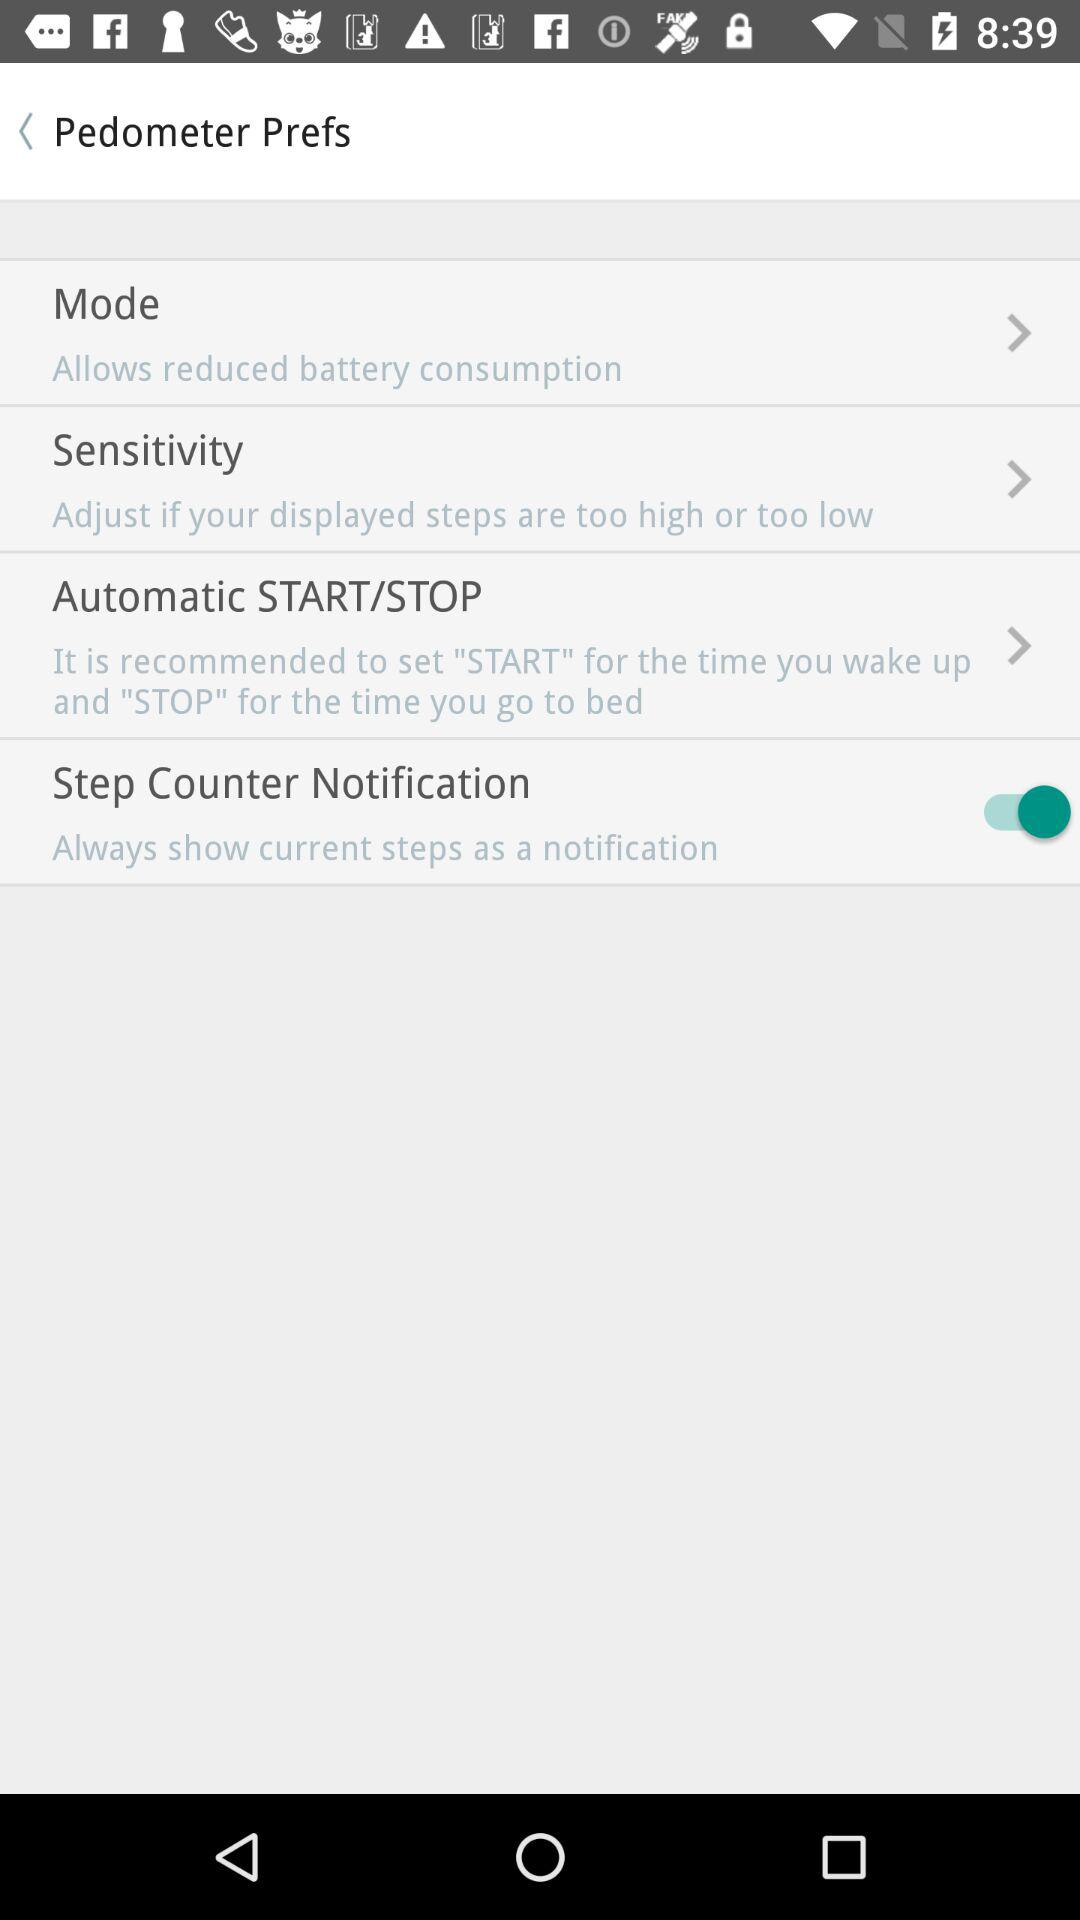How many items are there in the Pedometer Preferences screen?
Answer the question using a single word or phrase. 4 